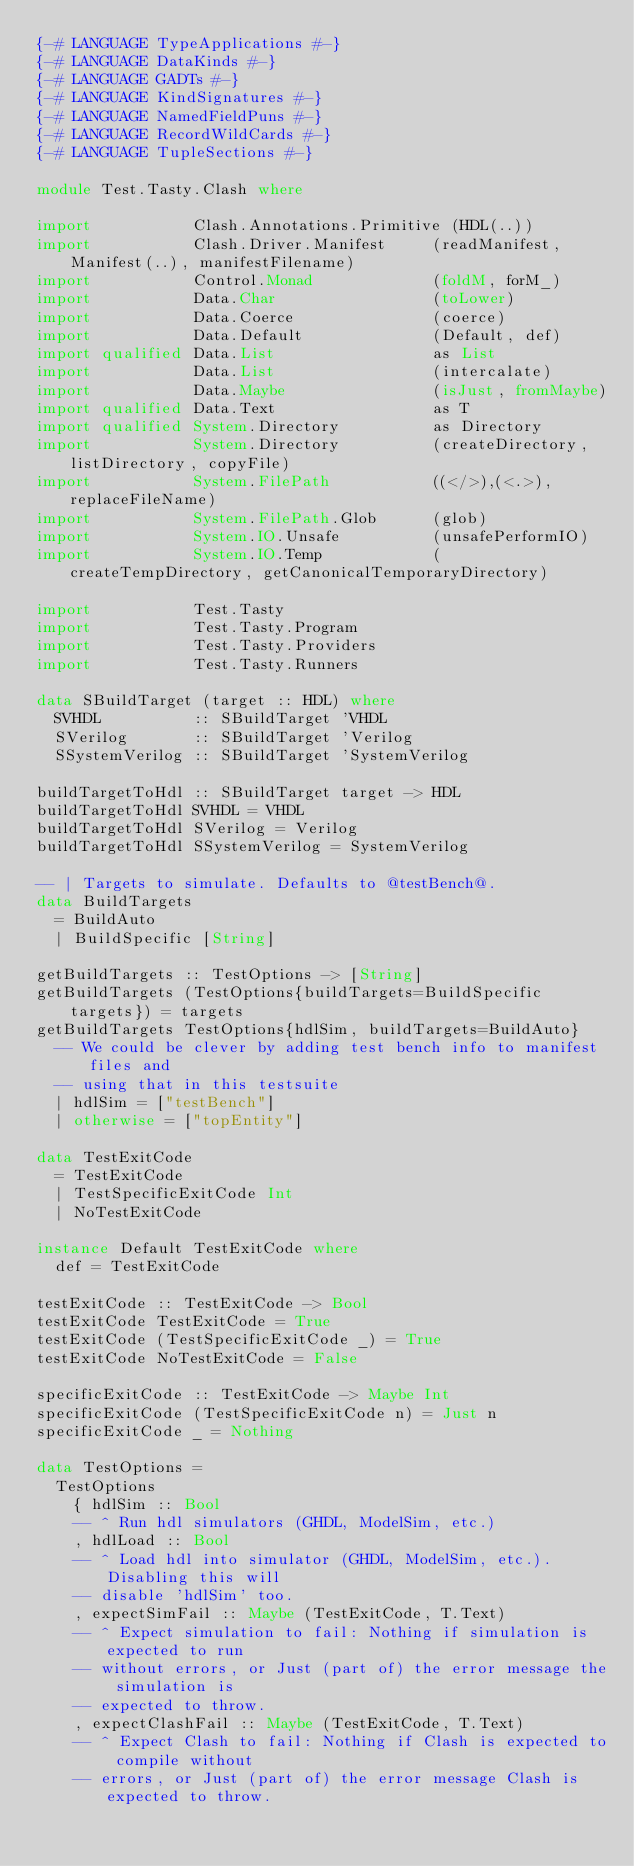Convert code to text. <code><loc_0><loc_0><loc_500><loc_500><_Haskell_>{-# LANGUAGE TypeApplications #-}
{-# LANGUAGE DataKinds #-}
{-# LANGUAGE GADTs #-}
{-# LANGUAGE KindSignatures #-}
{-# LANGUAGE NamedFieldPuns #-}
{-# LANGUAGE RecordWildCards #-}
{-# LANGUAGE TupleSections #-}

module Test.Tasty.Clash where

import           Clash.Annotations.Primitive (HDL(..))
import           Clash.Driver.Manifest     (readManifest, Manifest(..), manifestFilename)
import           Control.Monad             (foldM, forM_)
import           Data.Char                 (toLower)
import           Data.Coerce               (coerce)
import           Data.Default              (Default, def)
import qualified Data.List                 as List
import           Data.List                 (intercalate)
import           Data.Maybe                (isJust, fromMaybe)
import qualified Data.Text                 as T
import qualified System.Directory          as Directory
import           System.Directory          (createDirectory, listDirectory, copyFile)
import           System.FilePath           ((</>),(<.>), replaceFileName)
import           System.FilePath.Glob      (glob)
import           System.IO.Unsafe          (unsafePerformIO)
import           System.IO.Temp            (createTempDirectory, getCanonicalTemporaryDirectory)

import           Test.Tasty
import           Test.Tasty.Program
import           Test.Tasty.Providers
import           Test.Tasty.Runners

data SBuildTarget (target :: HDL) where
  SVHDL          :: SBuildTarget 'VHDL
  SVerilog       :: SBuildTarget 'Verilog
  SSystemVerilog :: SBuildTarget 'SystemVerilog

buildTargetToHdl :: SBuildTarget target -> HDL
buildTargetToHdl SVHDL = VHDL
buildTargetToHdl SVerilog = Verilog
buildTargetToHdl SSystemVerilog = SystemVerilog

-- | Targets to simulate. Defaults to @testBench@.
data BuildTargets
  = BuildAuto
  | BuildSpecific [String]

getBuildTargets :: TestOptions -> [String]
getBuildTargets (TestOptions{buildTargets=BuildSpecific targets}) = targets
getBuildTargets TestOptions{hdlSim, buildTargets=BuildAuto}
  -- We could be clever by adding test bench info to manifest files and
  -- using that in this testsuite
  | hdlSim = ["testBench"]
  | otherwise = ["topEntity"]

data TestExitCode
  = TestExitCode
  | TestSpecificExitCode Int
  | NoTestExitCode

instance Default TestExitCode where
  def = TestExitCode

testExitCode :: TestExitCode -> Bool
testExitCode TestExitCode = True
testExitCode (TestSpecificExitCode _) = True
testExitCode NoTestExitCode = False

specificExitCode :: TestExitCode -> Maybe Int
specificExitCode (TestSpecificExitCode n) = Just n
specificExitCode _ = Nothing

data TestOptions =
  TestOptions
    { hdlSim :: Bool
    -- ^ Run hdl simulators (GHDL, ModelSim, etc.)
    , hdlLoad :: Bool
    -- ^ Load hdl into simulator (GHDL, ModelSim, etc.). Disabling this will
    -- disable 'hdlSim' too.
    , expectSimFail :: Maybe (TestExitCode, T.Text)
    -- ^ Expect simulation to fail: Nothing if simulation is expected to run
    -- without errors, or Just (part of) the error message the simulation is
    -- expected to throw.
    , expectClashFail :: Maybe (TestExitCode, T.Text)
    -- ^ Expect Clash to fail: Nothing if Clash is expected to compile without
    -- errors, or Just (part of) the error message Clash is expected to throw.</code> 